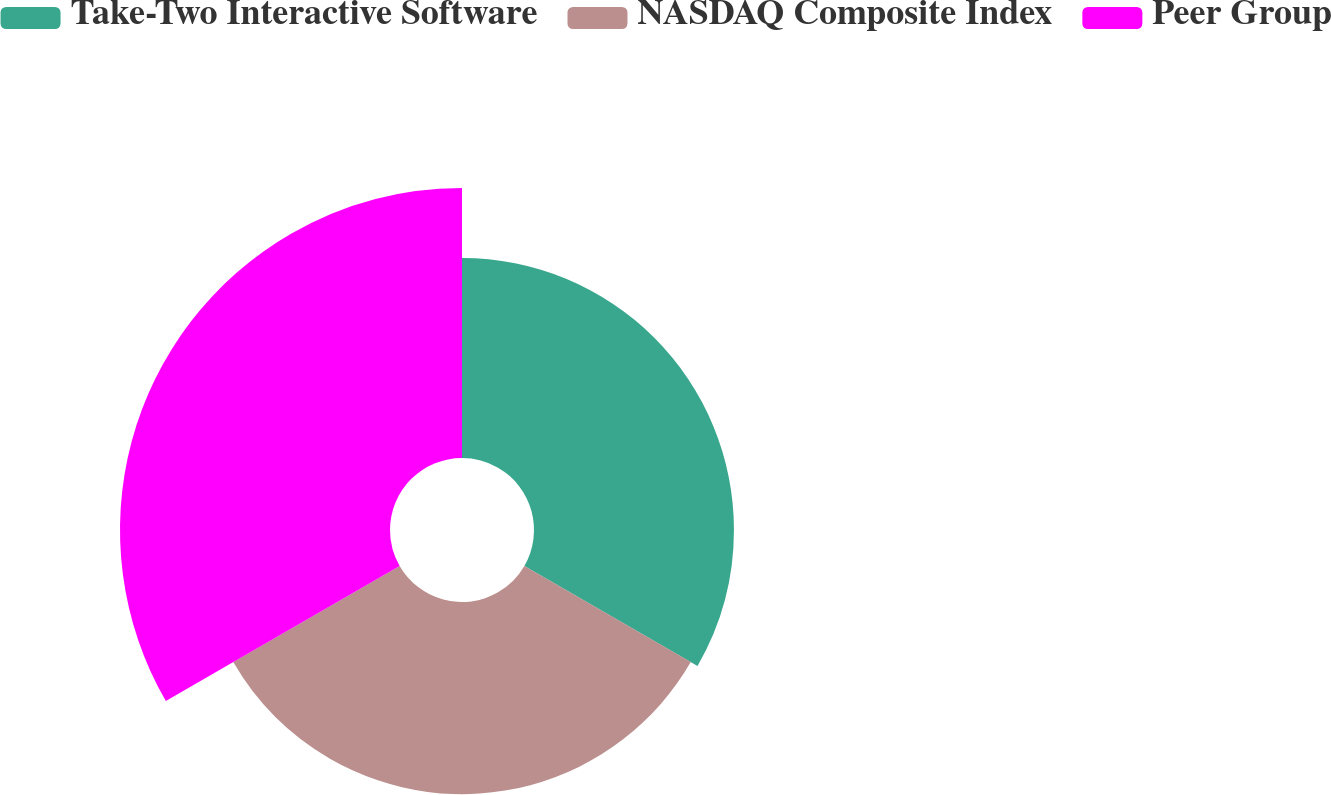Convert chart. <chart><loc_0><loc_0><loc_500><loc_500><pie_chart><fcel>Take-Two Interactive Software<fcel>NASDAQ Composite Index<fcel>Peer Group<nl><fcel>30.2%<fcel>29.02%<fcel>40.78%<nl></chart> 